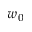Convert formula to latex. <formula><loc_0><loc_0><loc_500><loc_500>w _ { 0 }</formula> 